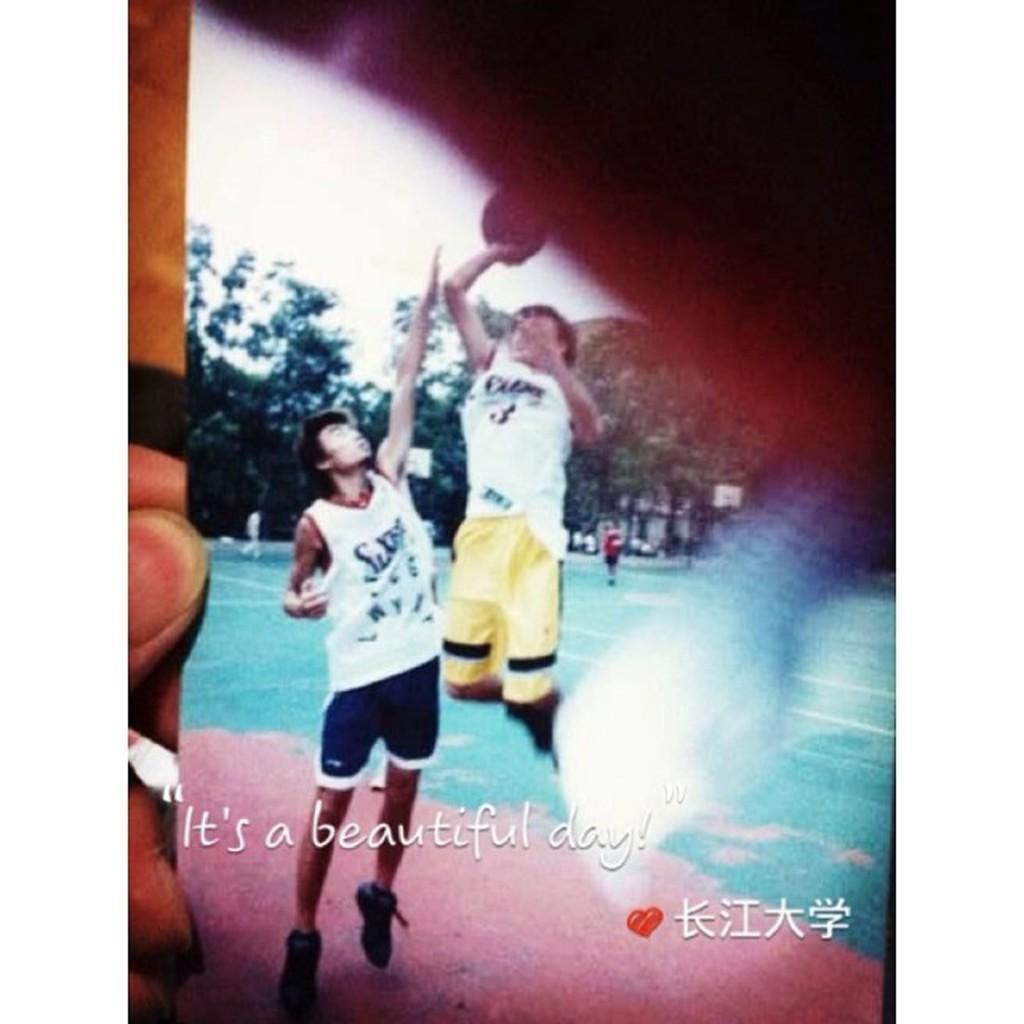In one or two sentences, can you explain what this image depicts? In this image we can see the photograph which includes people, trees and the sky. 